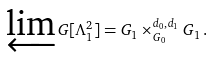<formula> <loc_0><loc_0><loc_500><loc_500>\varprojlim G [ \Lambda ^ { 2 } _ { 1 } ] = G _ { 1 } \times _ { G _ { 0 } } ^ { d _ { 0 } , d _ { 1 } } G _ { 1 } \, .</formula> 